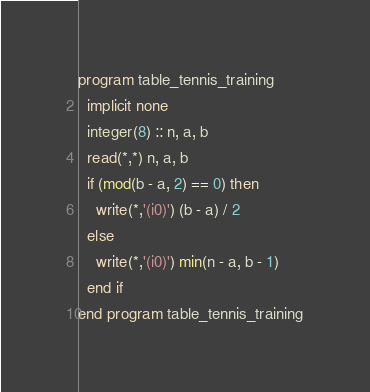<code> <loc_0><loc_0><loc_500><loc_500><_FORTRAN_>program table_tennis_training
  implicit none
  integer(8) :: n, a, b
  read(*,*) n, a, b
  if (mod(b - a, 2) == 0) then
    write(*,'(i0)') (b - a) / 2
  else
    write(*,'(i0)') min(n - a, b - 1)
  end if
end program table_tennis_training</code> 